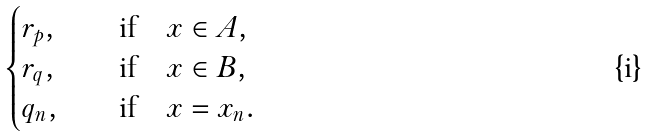Convert formula to latex. <formula><loc_0><loc_0><loc_500><loc_500>\begin{cases} r _ { p } , \quad & \text {if} \quad x \in A , \\ r _ { q } , \quad & \text {if} \quad x \in B , \\ q _ { n } , \quad & \text {if} \quad x = x _ { n } . \end{cases}</formula> 